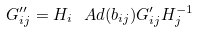Convert formula to latex. <formula><loc_0><loc_0><loc_500><loc_500>G ^ { \prime \prime } _ { i j } = H _ { i } \ A d ( b _ { i j } ) G ^ { \prime } _ { i j } H _ { j } ^ { - 1 }</formula> 